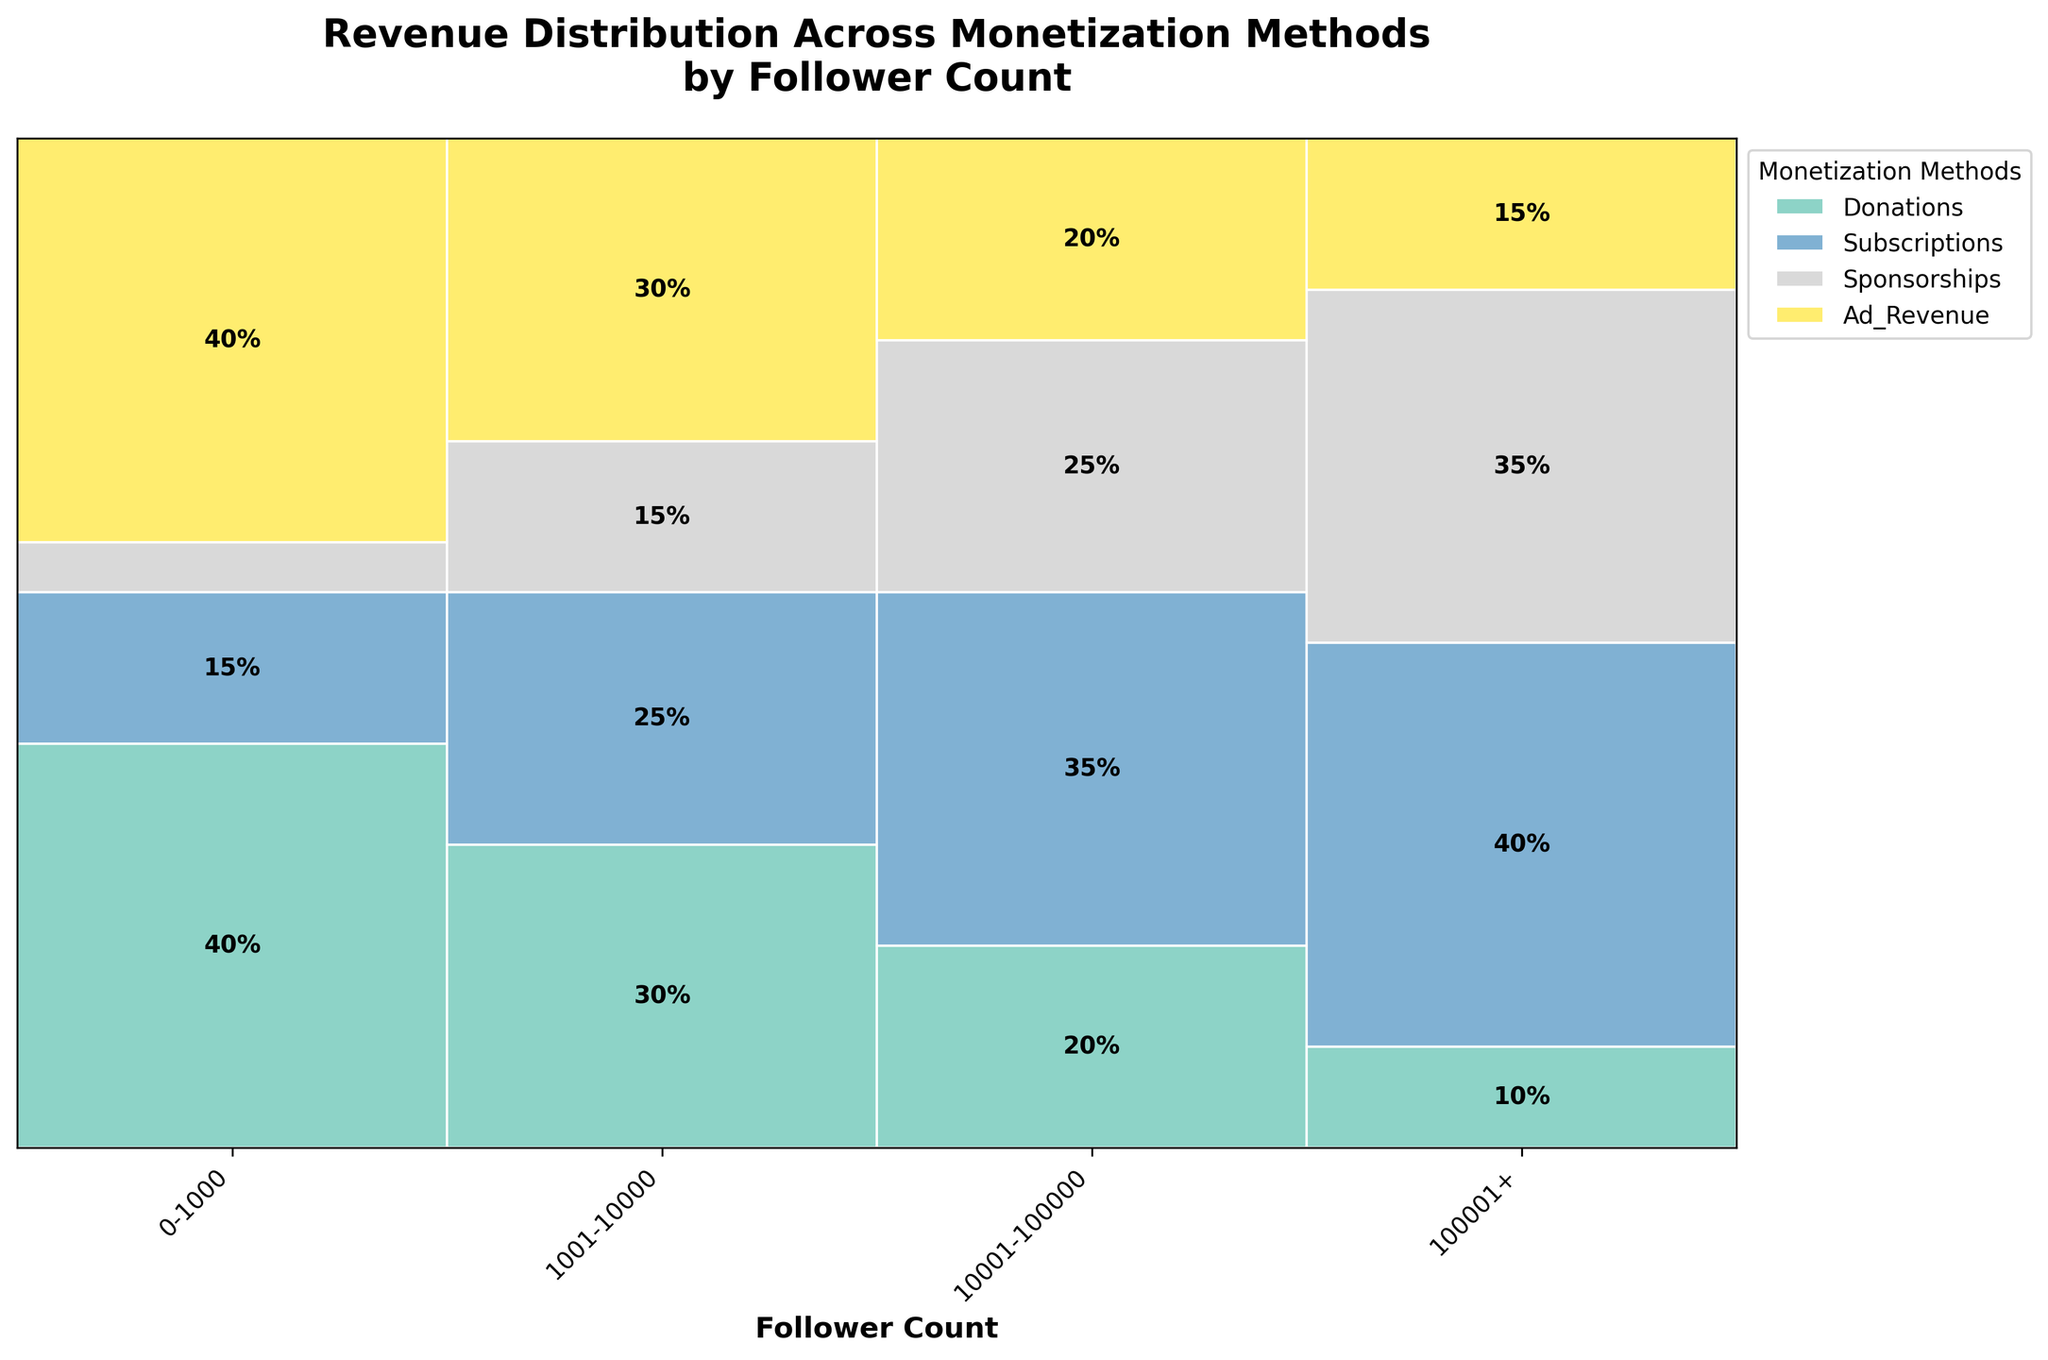What's the title of the plot? The title is at the top of the plot, usually in a larger or bolder text. Reading it directly tells us the subject of the plot.
Answer: Revenue Distribution Across Monetization Methods by Follower Count How is the revenue from donations distributed for streamers with different follower counts? Observing the different segments under 'Donations' across each follower count category, we see that the percentages decrease as follower count increases: 0-1000 (40%), 1001-10000 (30%), 10001-100000 (20%), 100001+ (10%).
Answer: It decreases as follower count increases Which monetization method is most prominent for streamers with 0-1000 followers? Look at the segments for the 0-1000 category. The largest segment is in 'Donations' and 'Ad Revenue’, both being 40%.
Answer: Donations and Ad Revenue How many monetization methods are displayed in the plot? Each method corresponds to a different color segment in the plot's legend. Counting these gives the number of monetization methods.
Answer: Four Which follower count group relies most on sponsorships? Look at the tallest segment for 'Sponsorships'. The group with the highest percentage is 100001+ with 35%.
Answer: 100001+ Compare the revenue distribution from subscriptions for streamers with 10001-100000 followers to those with 100001+ followers. Check the heights of the 'Subscriptions' segments for these two follower counts. For 10001-100000, it's 35%. For 100001+, it's 40%.
Answer: 100001+ has a higher percentage For streamers with 1001-10000 followers, what is the combined percentage for subscriptions and ad revenue? Add the two percentages: Subscriptions (25%) + Ad Revenue (30%) = 55%.
Answer: 55% Which follower group shows the most even distribution among all monetization methods? Looking for similarly sized segments within a single follower group. 1001-10000 appears most even.
Answer: 1001-10000 What are the monetization methods ranked by their revenue percentage for streamers with 10001-100000 followers? Order the percentages within the 10001-100000 group: Subscriptions (35%), Sponsorships (25%), Donations (20%), Ad Revenue (20%).
Answer: Subscriptions > Sponsorships > Donations = Ad Revenue 